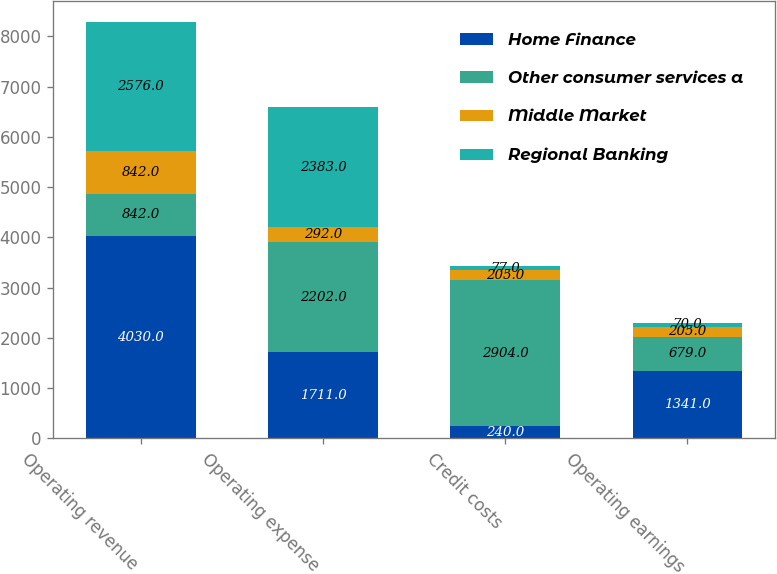<chart> <loc_0><loc_0><loc_500><loc_500><stacked_bar_chart><ecel><fcel>Operating revenue<fcel>Operating expense<fcel>Credit costs<fcel>Operating earnings<nl><fcel>Home Finance<fcel>4030<fcel>1711<fcel>240<fcel>1341<nl><fcel>Other consumer services a<fcel>842<fcel>2202<fcel>2904<fcel>679<nl><fcel>Middle Market<fcel>842<fcel>292<fcel>205<fcel>205<nl><fcel>Regional Banking<fcel>2576<fcel>2383<fcel>77<fcel>70<nl></chart> 